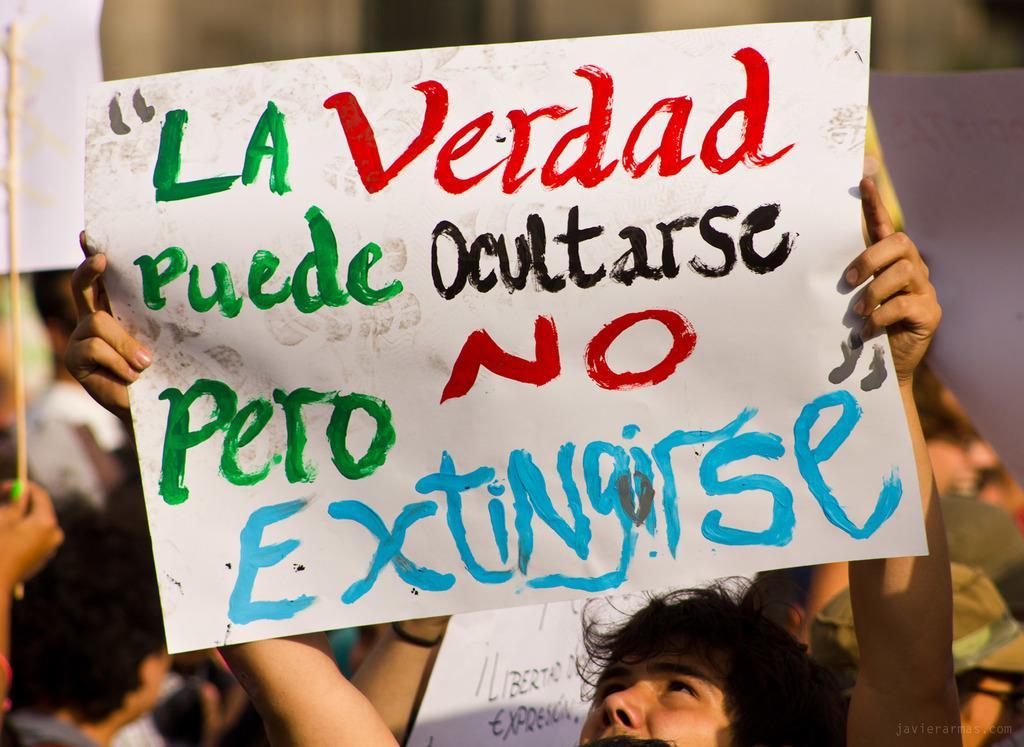Can you describe this image briefly? In this image, at the bottom there is a man, he is holding a poster on that there is a text. In the background there are people, posters, sticks. 